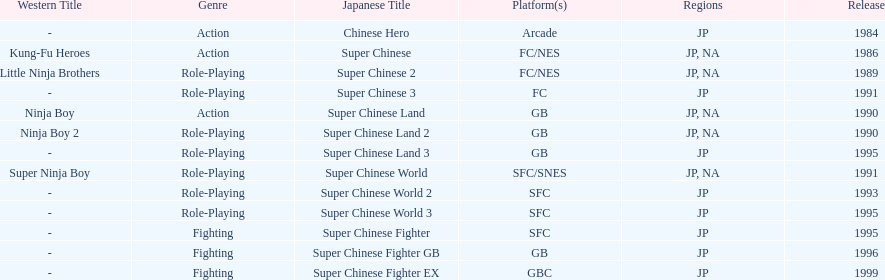What's the overall count of super chinese games that have been launched? 13. 